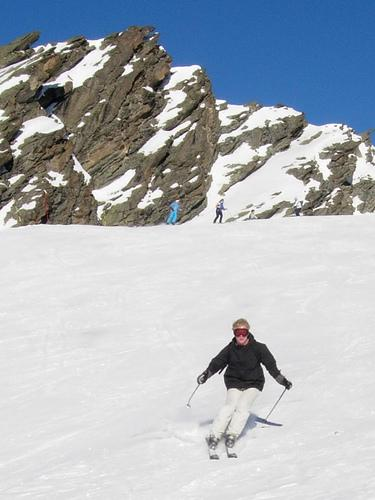What is the geological rock formation called? mountain 